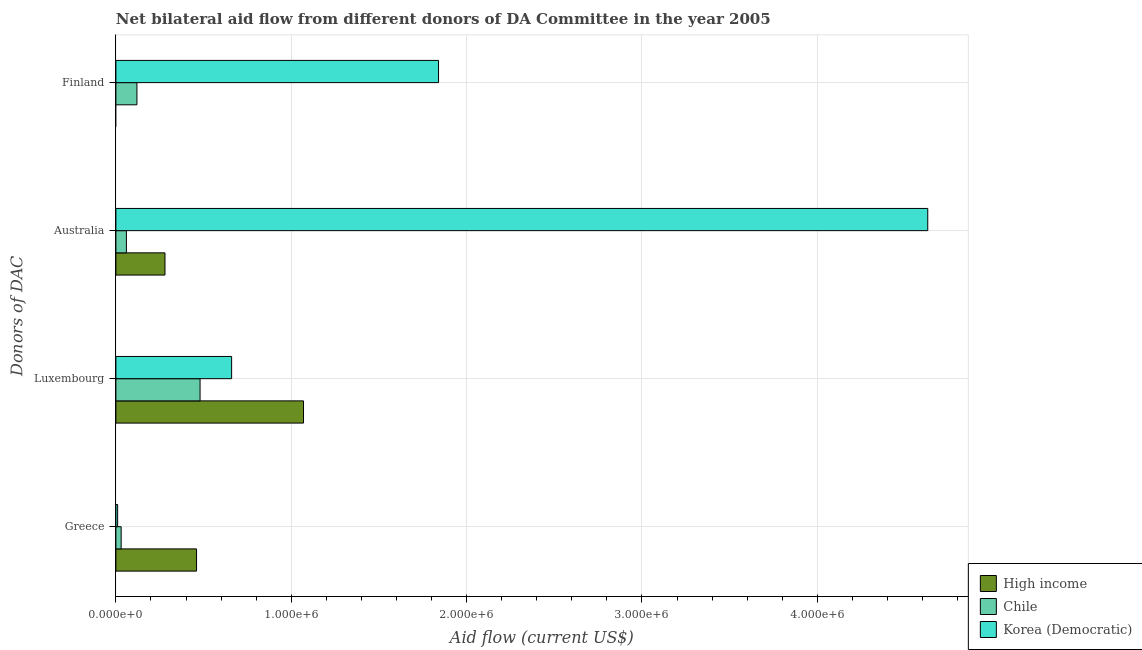Are the number of bars on each tick of the Y-axis equal?
Offer a very short reply. No. What is the label of the 3rd group of bars from the top?
Offer a terse response. Luxembourg. What is the amount of aid given by greece in Chile?
Provide a succinct answer. 3.00e+04. Across all countries, what is the maximum amount of aid given by luxembourg?
Give a very brief answer. 1.07e+06. Across all countries, what is the minimum amount of aid given by australia?
Give a very brief answer. 6.00e+04. In which country was the amount of aid given by finland maximum?
Keep it short and to the point. Korea (Democratic). What is the total amount of aid given by greece in the graph?
Make the answer very short. 5.00e+05. What is the difference between the amount of aid given by luxembourg in Korea (Democratic) and that in High income?
Your response must be concise. -4.10e+05. What is the difference between the amount of aid given by finland in Chile and the amount of aid given by luxembourg in Korea (Democratic)?
Offer a very short reply. -5.40e+05. What is the average amount of aid given by finland per country?
Provide a succinct answer. 6.53e+05. What is the difference between the amount of aid given by finland and amount of aid given by luxembourg in Korea (Democratic)?
Your answer should be very brief. 1.18e+06. What is the ratio of the amount of aid given by australia in High income to that in Chile?
Your answer should be compact. 4.67. Is the amount of aid given by finland in Chile less than that in Korea (Democratic)?
Keep it short and to the point. Yes. Is the difference between the amount of aid given by finland in Chile and Korea (Democratic) greater than the difference between the amount of aid given by luxembourg in Chile and Korea (Democratic)?
Provide a succinct answer. No. What is the difference between the highest and the second highest amount of aid given by greece?
Provide a succinct answer. 4.30e+05. What is the difference between the highest and the lowest amount of aid given by australia?
Offer a very short reply. 4.57e+06. Is the sum of the amount of aid given by australia in Korea (Democratic) and Chile greater than the maximum amount of aid given by finland across all countries?
Offer a very short reply. Yes. Is it the case that in every country, the sum of the amount of aid given by luxembourg and amount of aid given by greece is greater than the sum of amount of aid given by finland and amount of aid given by australia?
Make the answer very short. No. Is it the case that in every country, the sum of the amount of aid given by greece and amount of aid given by luxembourg is greater than the amount of aid given by australia?
Ensure brevity in your answer.  No. How many countries are there in the graph?
Offer a terse response. 3. Where does the legend appear in the graph?
Ensure brevity in your answer.  Bottom right. How are the legend labels stacked?
Offer a very short reply. Vertical. What is the title of the graph?
Make the answer very short. Net bilateral aid flow from different donors of DA Committee in the year 2005. What is the label or title of the Y-axis?
Your answer should be compact. Donors of DAC. What is the Aid flow (current US$) of Korea (Democratic) in Greece?
Make the answer very short. 10000. What is the Aid flow (current US$) of High income in Luxembourg?
Your answer should be compact. 1.07e+06. What is the Aid flow (current US$) of Chile in Luxembourg?
Offer a very short reply. 4.80e+05. What is the Aid flow (current US$) of Korea (Democratic) in Luxembourg?
Ensure brevity in your answer.  6.60e+05. What is the Aid flow (current US$) of Korea (Democratic) in Australia?
Offer a very short reply. 4.63e+06. What is the Aid flow (current US$) of Korea (Democratic) in Finland?
Offer a terse response. 1.84e+06. Across all Donors of DAC, what is the maximum Aid flow (current US$) of High income?
Keep it short and to the point. 1.07e+06. Across all Donors of DAC, what is the maximum Aid flow (current US$) of Chile?
Offer a very short reply. 4.80e+05. Across all Donors of DAC, what is the maximum Aid flow (current US$) of Korea (Democratic)?
Provide a short and direct response. 4.63e+06. Across all Donors of DAC, what is the minimum Aid flow (current US$) of Korea (Democratic)?
Your answer should be very brief. 10000. What is the total Aid flow (current US$) of High income in the graph?
Make the answer very short. 1.81e+06. What is the total Aid flow (current US$) in Chile in the graph?
Ensure brevity in your answer.  6.90e+05. What is the total Aid flow (current US$) in Korea (Democratic) in the graph?
Your answer should be very brief. 7.14e+06. What is the difference between the Aid flow (current US$) of High income in Greece and that in Luxembourg?
Give a very brief answer. -6.10e+05. What is the difference between the Aid flow (current US$) in Chile in Greece and that in Luxembourg?
Ensure brevity in your answer.  -4.50e+05. What is the difference between the Aid flow (current US$) in Korea (Democratic) in Greece and that in Luxembourg?
Ensure brevity in your answer.  -6.50e+05. What is the difference between the Aid flow (current US$) in Korea (Democratic) in Greece and that in Australia?
Provide a short and direct response. -4.62e+06. What is the difference between the Aid flow (current US$) of Chile in Greece and that in Finland?
Ensure brevity in your answer.  -9.00e+04. What is the difference between the Aid flow (current US$) in Korea (Democratic) in Greece and that in Finland?
Your answer should be compact. -1.83e+06. What is the difference between the Aid flow (current US$) of High income in Luxembourg and that in Australia?
Make the answer very short. 7.90e+05. What is the difference between the Aid flow (current US$) in Korea (Democratic) in Luxembourg and that in Australia?
Keep it short and to the point. -3.97e+06. What is the difference between the Aid flow (current US$) in Korea (Democratic) in Luxembourg and that in Finland?
Offer a very short reply. -1.18e+06. What is the difference between the Aid flow (current US$) of Chile in Australia and that in Finland?
Ensure brevity in your answer.  -6.00e+04. What is the difference between the Aid flow (current US$) of Korea (Democratic) in Australia and that in Finland?
Offer a very short reply. 2.79e+06. What is the difference between the Aid flow (current US$) of High income in Greece and the Aid flow (current US$) of Chile in Luxembourg?
Make the answer very short. -2.00e+04. What is the difference between the Aid flow (current US$) of Chile in Greece and the Aid flow (current US$) of Korea (Democratic) in Luxembourg?
Give a very brief answer. -6.30e+05. What is the difference between the Aid flow (current US$) in High income in Greece and the Aid flow (current US$) in Chile in Australia?
Ensure brevity in your answer.  4.00e+05. What is the difference between the Aid flow (current US$) of High income in Greece and the Aid flow (current US$) of Korea (Democratic) in Australia?
Make the answer very short. -4.17e+06. What is the difference between the Aid flow (current US$) in Chile in Greece and the Aid flow (current US$) in Korea (Democratic) in Australia?
Ensure brevity in your answer.  -4.60e+06. What is the difference between the Aid flow (current US$) in High income in Greece and the Aid flow (current US$) in Korea (Democratic) in Finland?
Ensure brevity in your answer.  -1.38e+06. What is the difference between the Aid flow (current US$) in Chile in Greece and the Aid flow (current US$) in Korea (Democratic) in Finland?
Provide a succinct answer. -1.81e+06. What is the difference between the Aid flow (current US$) in High income in Luxembourg and the Aid flow (current US$) in Chile in Australia?
Offer a terse response. 1.01e+06. What is the difference between the Aid flow (current US$) in High income in Luxembourg and the Aid flow (current US$) in Korea (Democratic) in Australia?
Make the answer very short. -3.56e+06. What is the difference between the Aid flow (current US$) of Chile in Luxembourg and the Aid flow (current US$) of Korea (Democratic) in Australia?
Ensure brevity in your answer.  -4.15e+06. What is the difference between the Aid flow (current US$) in High income in Luxembourg and the Aid flow (current US$) in Chile in Finland?
Your answer should be compact. 9.50e+05. What is the difference between the Aid flow (current US$) in High income in Luxembourg and the Aid flow (current US$) in Korea (Democratic) in Finland?
Keep it short and to the point. -7.70e+05. What is the difference between the Aid flow (current US$) of Chile in Luxembourg and the Aid flow (current US$) of Korea (Democratic) in Finland?
Ensure brevity in your answer.  -1.36e+06. What is the difference between the Aid flow (current US$) of High income in Australia and the Aid flow (current US$) of Chile in Finland?
Provide a short and direct response. 1.60e+05. What is the difference between the Aid flow (current US$) in High income in Australia and the Aid flow (current US$) in Korea (Democratic) in Finland?
Provide a succinct answer. -1.56e+06. What is the difference between the Aid flow (current US$) of Chile in Australia and the Aid flow (current US$) of Korea (Democratic) in Finland?
Your response must be concise. -1.78e+06. What is the average Aid flow (current US$) of High income per Donors of DAC?
Give a very brief answer. 4.52e+05. What is the average Aid flow (current US$) in Chile per Donors of DAC?
Give a very brief answer. 1.72e+05. What is the average Aid flow (current US$) of Korea (Democratic) per Donors of DAC?
Keep it short and to the point. 1.78e+06. What is the difference between the Aid flow (current US$) of High income and Aid flow (current US$) of Korea (Democratic) in Greece?
Make the answer very short. 4.50e+05. What is the difference between the Aid flow (current US$) in High income and Aid flow (current US$) in Chile in Luxembourg?
Your answer should be very brief. 5.90e+05. What is the difference between the Aid flow (current US$) of Chile and Aid flow (current US$) of Korea (Democratic) in Luxembourg?
Ensure brevity in your answer.  -1.80e+05. What is the difference between the Aid flow (current US$) in High income and Aid flow (current US$) in Chile in Australia?
Your response must be concise. 2.20e+05. What is the difference between the Aid flow (current US$) of High income and Aid flow (current US$) of Korea (Democratic) in Australia?
Your response must be concise. -4.35e+06. What is the difference between the Aid flow (current US$) in Chile and Aid flow (current US$) in Korea (Democratic) in Australia?
Your answer should be very brief. -4.57e+06. What is the difference between the Aid flow (current US$) of Chile and Aid flow (current US$) of Korea (Democratic) in Finland?
Your answer should be very brief. -1.72e+06. What is the ratio of the Aid flow (current US$) of High income in Greece to that in Luxembourg?
Ensure brevity in your answer.  0.43. What is the ratio of the Aid flow (current US$) in Chile in Greece to that in Luxembourg?
Offer a very short reply. 0.06. What is the ratio of the Aid flow (current US$) in Korea (Democratic) in Greece to that in Luxembourg?
Keep it short and to the point. 0.02. What is the ratio of the Aid flow (current US$) of High income in Greece to that in Australia?
Give a very brief answer. 1.64. What is the ratio of the Aid flow (current US$) in Korea (Democratic) in Greece to that in Australia?
Make the answer very short. 0. What is the ratio of the Aid flow (current US$) of Korea (Democratic) in Greece to that in Finland?
Offer a terse response. 0.01. What is the ratio of the Aid flow (current US$) in High income in Luxembourg to that in Australia?
Keep it short and to the point. 3.82. What is the ratio of the Aid flow (current US$) in Chile in Luxembourg to that in Australia?
Offer a terse response. 8. What is the ratio of the Aid flow (current US$) of Korea (Democratic) in Luxembourg to that in Australia?
Your response must be concise. 0.14. What is the ratio of the Aid flow (current US$) of Chile in Luxembourg to that in Finland?
Your answer should be compact. 4. What is the ratio of the Aid flow (current US$) of Korea (Democratic) in Luxembourg to that in Finland?
Make the answer very short. 0.36. What is the ratio of the Aid flow (current US$) of Chile in Australia to that in Finland?
Keep it short and to the point. 0.5. What is the ratio of the Aid flow (current US$) in Korea (Democratic) in Australia to that in Finland?
Your answer should be very brief. 2.52. What is the difference between the highest and the second highest Aid flow (current US$) of High income?
Provide a short and direct response. 6.10e+05. What is the difference between the highest and the second highest Aid flow (current US$) of Chile?
Provide a succinct answer. 3.60e+05. What is the difference between the highest and the second highest Aid flow (current US$) in Korea (Democratic)?
Your answer should be very brief. 2.79e+06. What is the difference between the highest and the lowest Aid flow (current US$) of High income?
Keep it short and to the point. 1.07e+06. What is the difference between the highest and the lowest Aid flow (current US$) in Chile?
Provide a short and direct response. 4.50e+05. What is the difference between the highest and the lowest Aid flow (current US$) of Korea (Democratic)?
Provide a succinct answer. 4.62e+06. 